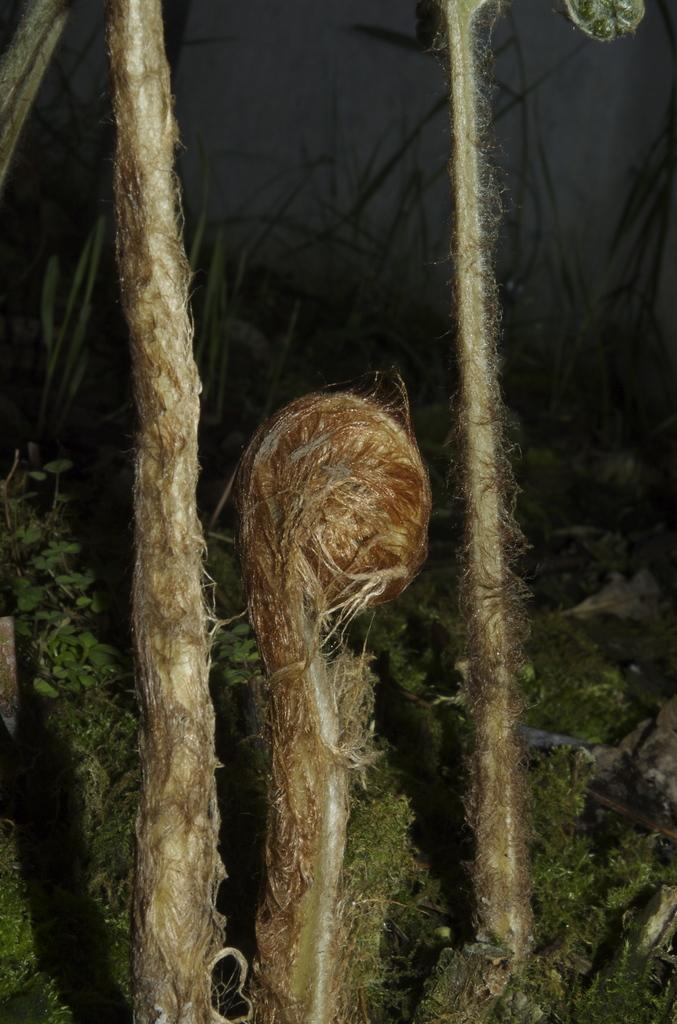What type of living organisms can be seen in the image? Plants and leaves are visible in the image. Can you describe the background of the image? The background of the image is dark. How many tomatoes can be seen hanging from the plants in the image? There are no tomatoes present in the image; only plants and leaves are visible. What type of vehicle is parked in the background of the image? There is no vehicle present in the image; the background is dark. 